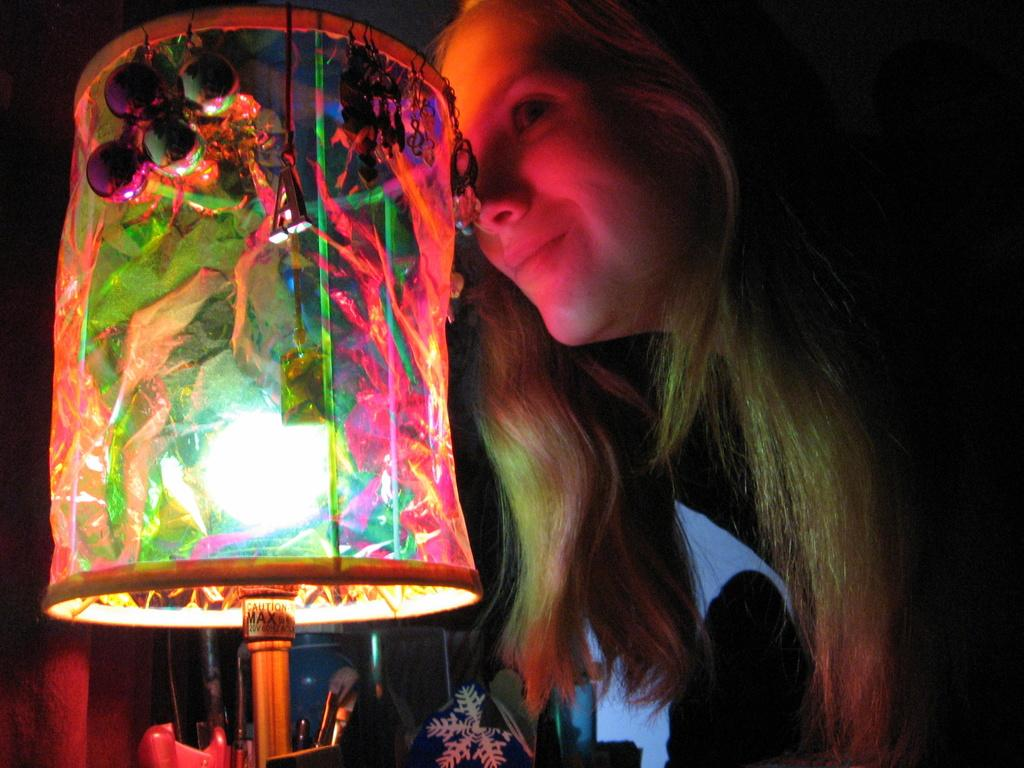What is located on the right side of the image? There is a woman on the right side of the image. What is the woman doing in the image? The woman is smiling and slightly bending. What can be seen on the table in the image? There is a light on the table, along with other objects. How would you describe the background of the image? The background of the image is dark in color. Who is the owner of the ant in the image? There are no ants present in the image, so it is not possible to determine the owner of an ant. 